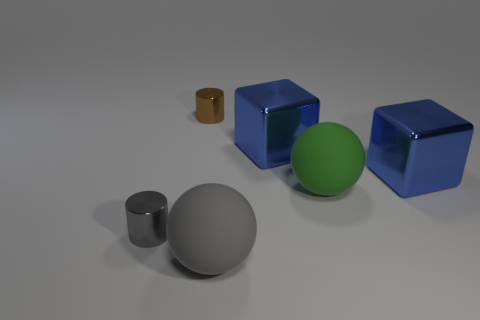There is a large green matte thing; is its shape the same as the gray thing that is to the right of the brown metallic object?
Give a very brief answer. Yes. The gray object in front of the metal cylinder in front of the shiny cylinder that is behind the large green object is made of what material?
Your response must be concise. Rubber. What number of other objects are there of the same size as the gray rubber ball?
Provide a short and direct response. 3. What number of brown shiny cylinders are behind the small shiny thing behind the large blue metal cube left of the green ball?
Ensure brevity in your answer.  0. The tiny cylinder behind the tiny cylinder that is in front of the large green ball is made of what material?
Make the answer very short. Metal. Is there another big matte thing that has the same shape as the gray matte thing?
Your response must be concise. Yes. There is a matte ball that is the same size as the gray matte object; what color is it?
Your answer should be very brief. Green. What number of things are either big spheres that are behind the gray metal cylinder or cylinders left of the tiny brown shiny cylinder?
Offer a very short reply. 2. How many things are either tiny gray objects or tiny brown shiny objects?
Keep it short and to the point. 2. There is a metal object that is left of the large gray matte sphere and in front of the brown metallic cylinder; how big is it?
Your answer should be very brief. Small. 